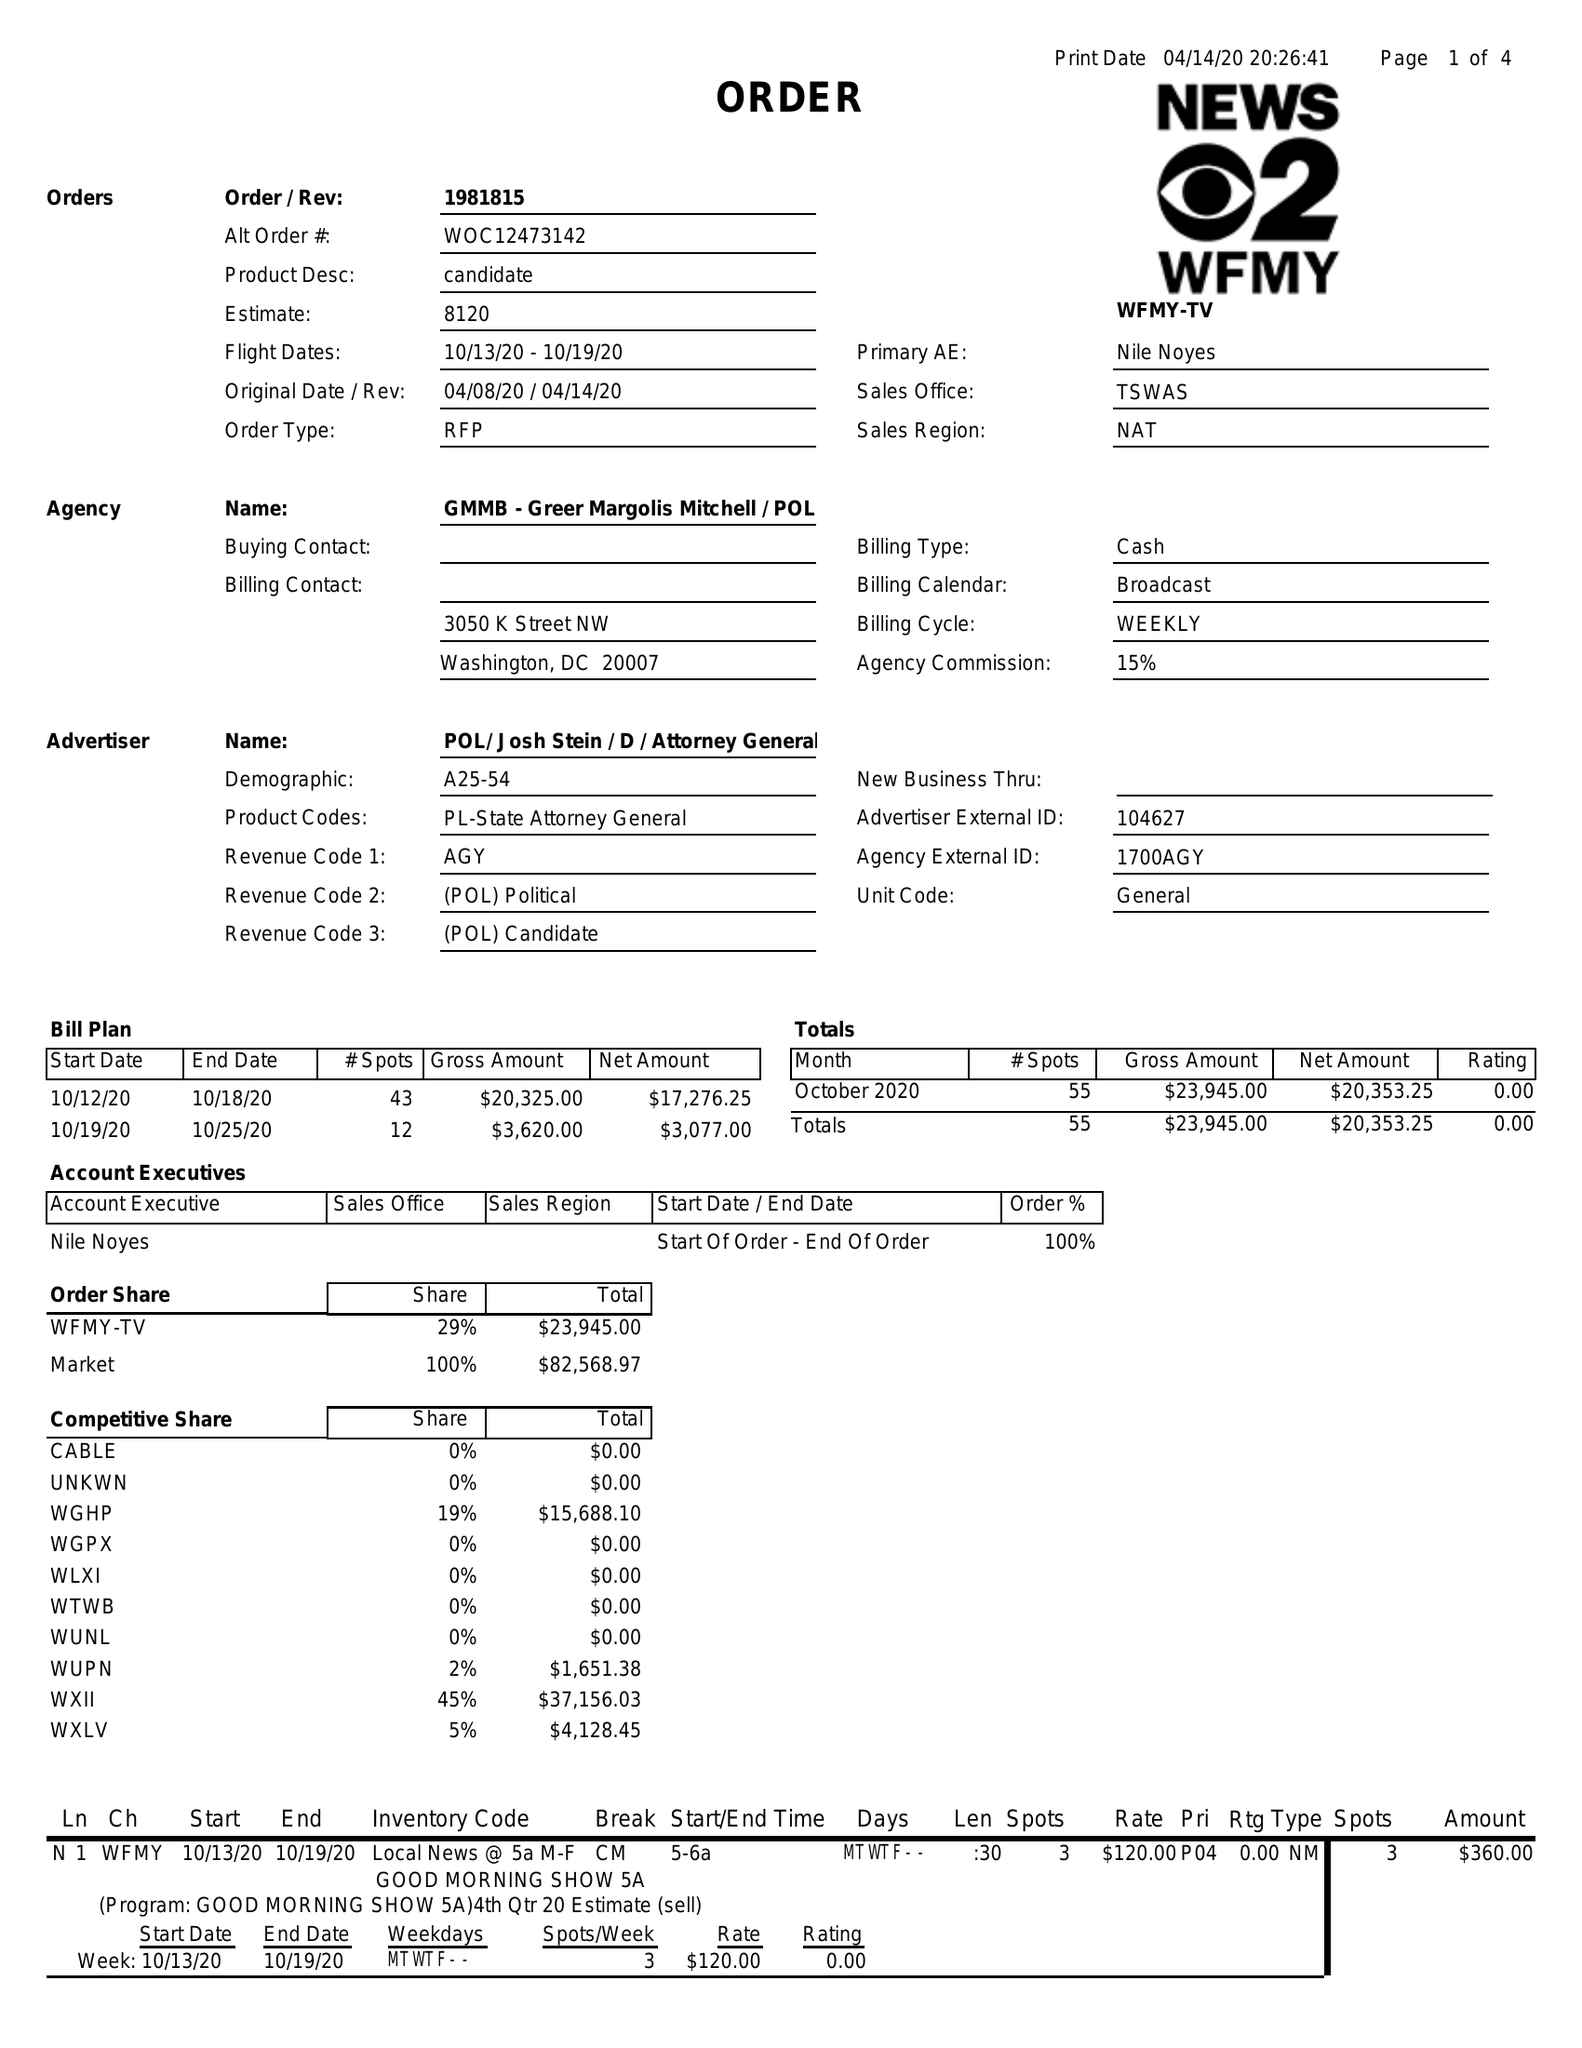What is the value for the flight_from?
Answer the question using a single word or phrase. 10/13/20 